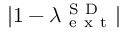<formula> <loc_0><loc_0><loc_500><loc_500>| 1 - \lambda _ { e x t } ^ { S D } |</formula> 